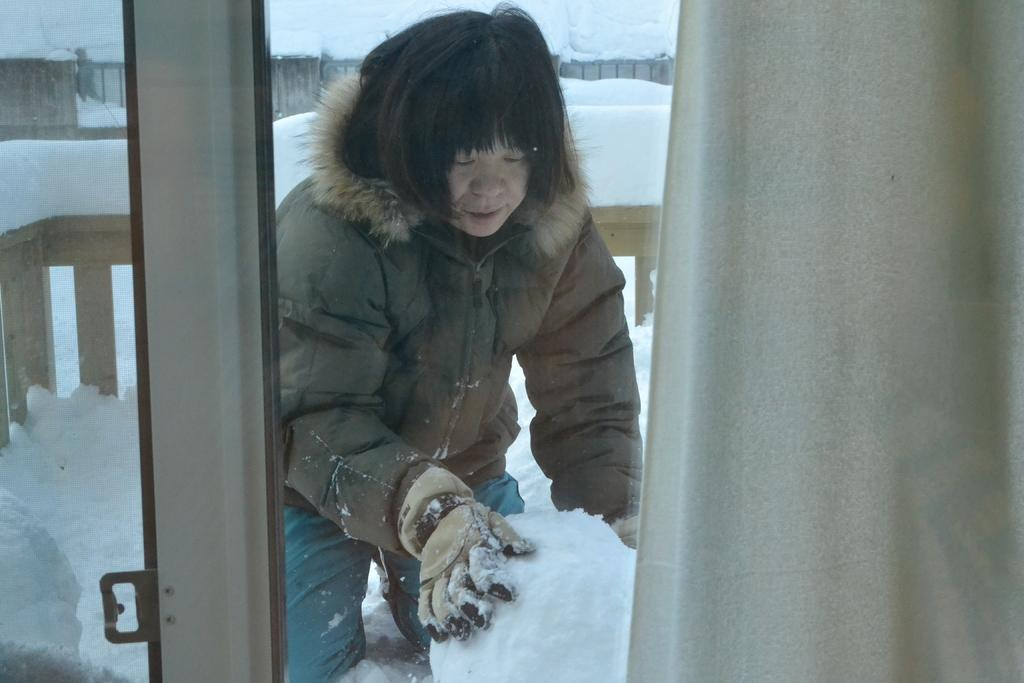What is present in the image that allows light to enter the room? There is a window in the image. What is used to cover the window? There is a curtain associated with the window. What activity is the person visible through the window engaged in? The person is making a snowball. What type of weather is depicted in the image? There is snow visible in the image. What architectural feature can be seen in the image? There are fences in the image. What type of beam can be seen supporting the roof in the image? There is no beam supporting the roof visible in the image. What is the taste of the snowball being made by the person in the image? The image does not provide any information about the taste of the snowball, as it only shows the person making it. 